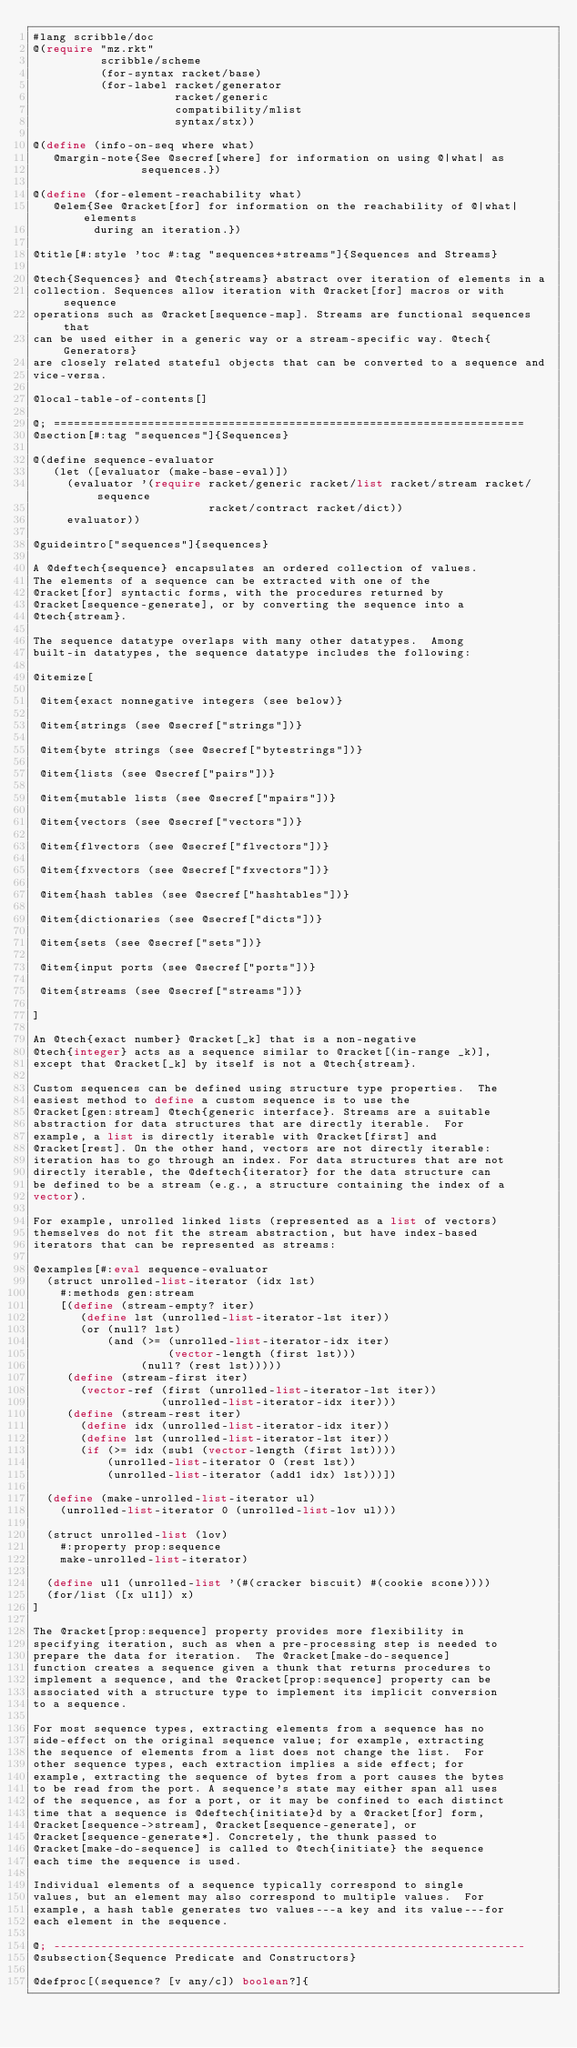Convert code to text. <code><loc_0><loc_0><loc_500><loc_500><_Racket_>#lang scribble/doc
@(require "mz.rkt"
          scribble/scheme
          (for-syntax racket/base)
          (for-label racket/generator
                     racket/generic
                     compatibility/mlist
                     syntax/stx))

@(define (info-on-seq where what)
   @margin-note{See @secref[where] for information on using @|what| as
                sequences.})

@(define (for-element-reachability what)
   @elem{See @racket[for] for information on the reachability of @|what| elements
         during an iteration.})

@title[#:style 'toc #:tag "sequences+streams"]{Sequences and Streams}

@tech{Sequences} and @tech{streams} abstract over iteration of elements in a
collection. Sequences allow iteration with @racket[for] macros or with sequence
operations such as @racket[sequence-map]. Streams are functional sequences that
can be used either in a generic way or a stream-specific way. @tech{Generators}
are closely related stateful objects that can be converted to a sequence and
vice-versa.

@local-table-of-contents[]

@; ======================================================================
@section[#:tag "sequences"]{Sequences}

@(define sequence-evaluator
   (let ([evaluator (make-base-eval)])
     (evaluator '(require racket/generic racket/list racket/stream racket/sequence
                          racket/contract racket/dict))
     evaluator))

@guideintro["sequences"]{sequences}

A @deftech{sequence} encapsulates an ordered collection of values.
The elements of a sequence can be extracted with one of the
@racket[for] syntactic forms, with the procedures returned by
@racket[sequence-generate], or by converting the sequence into a
@tech{stream}.

The sequence datatype overlaps with many other datatypes.  Among
built-in datatypes, the sequence datatype includes the following:

@itemize[

 @item{exact nonnegative integers (see below)}

 @item{strings (see @secref["strings"])}

 @item{byte strings (see @secref["bytestrings"])}

 @item{lists (see @secref["pairs"])}

 @item{mutable lists (see @secref["mpairs"])}

 @item{vectors (see @secref["vectors"])}

 @item{flvectors (see @secref["flvectors"])}

 @item{fxvectors (see @secref["fxvectors"])}

 @item{hash tables (see @secref["hashtables"])}

 @item{dictionaries (see @secref["dicts"])}

 @item{sets (see @secref["sets"])}

 @item{input ports (see @secref["ports"])}

 @item{streams (see @secref["streams"])}

]

An @tech{exact number} @racket[_k] that is a non-negative
@tech{integer} acts as a sequence similar to @racket[(in-range _k)],
except that @racket[_k] by itself is not a @tech{stream}.

Custom sequences can be defined using structure type properties.  The
easiest method to define a custom sequence is to use the
@racket[gen:stream] @tech{generic interface}. Streams are a suitable
abstraction for data structures that are directly iterable.  For
example, a list is directly iterable with @racket[first] and
@racket[rest]. On the other hand, vectors are not directly iterable:
iteration has to go through an index. For data structures that are not
directly iterable, the @deftech{iterator} for the data structure can
be defined to be a stream (e.g., a structure containing the index of a
vector).

For example, unrolled linked lists (represented as a list of vectors)
themselves do not fit the stream abstraction, but have index-based
iterators that can be represented as streams:

@examples[#:eval sequence-evaluator
  (struct unrolled-list-iterator (idx lst)
    #:methods gen:stream
    [(define (stream-empty? iter)
       (define lst (unrolled-list-iterator-lst iter))
       (or (null? lst)
           (and (>= (unrolled-list-iterator-idx iter)
                    (vector-length (first lst)))
                (null? (rest lst)))))
     (define (stream-first iter)
       (vector-ref (first (unrolled-list-iterator-lst iter))
                   (unrolled-list-iterator-idx iter)))
     (define (stream-rest iter)
       (define idx (unrolled-list-iterator-idx iter))
       (define lst (unrolled-list-iterator-lst iter))
       (if (>= idx (sub1 (vector-length (first lst))))
           (unrolled-list-iterator 0 (rest lst))
           (unrolled-list-iterator (add1 idx) lst)))])

  (define (make-unrolled-list-iterator ul)
    (unrolled-list-iterator 0 (unrolled-list-lov ul)))

  (struct unrolled-list (lov)
    #:property prop:sequence
    make-unrolled-list-iterator)

  (define ul1 (unrolled-list '(#(cracker biscuit) #(cookie scone))))
  (for/list ([x ul1]) x)
]

The @racket[prop:sequence] property provides more flexibility in
specifying iteration, such as when a pre-processing step is needed to
prepare the data for iteration.  The @racket[make-do-sequence]
function creates a sequence given a thunk that returns procedures to
implement a sequence, and the @racket[prop:sequence] property can be
associated with a structure type to implement its implicit conversion
to a sequence.

For most sequence types, extracting elements from a sequence has no
side-effect on the original sequence value; for example, extracting
the sequence of elements from a list does not change the list.  For
other sequence types, each extraction implies a side effect; for
example, extracting the sequence of bytes from a port causes the bytes
to be read from the port. A sequence's state may either span all uses
of the sequence, as for a port, or it may be confined to each distinct
time that a sequence is @deftech{initiate}d by a @racket[for] form,
@racket[sequence->stream], @racket[sequence-generate], or
@racket[sequence-generate*]. Concretely, the thunk passed to
@racket[make-do-sequence] is called to @tech{initiate} the sequence
each time the sequence is used.

Individual elements of a sequence typically correspond to single
values, but an element may also correspond to multiple values.  For
example, a hash table generates two values---a key and its value---for
each element in the sequence.

@; ----------------------------------------------------------------------
@subsection{Sequence Predicate and Constructors}

@defproc[(sequence? [v any/c]) boolean?]{</code> 